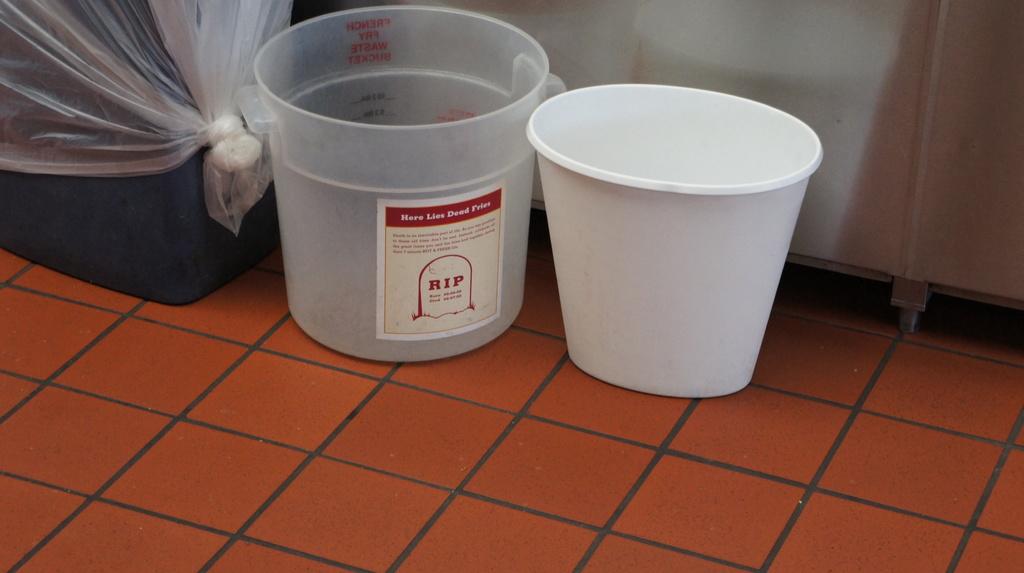What kind of fries is the bucket for?
Ensure brevity in your answer.  Rip. What three letters are in bold red?
Ensure brevity in your answer.  Rip. 